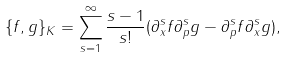Convert formula to latex. <formula><loc_0><loc_0><loc_500><loc_500>\{ f , g \} _ { K } = \sum _ { s = 1 } ^ { \infty } \frac { s - 1 } { s ! } ( \partial _ { x } ^ { s } f \partial _ { p } ^ { s } g - \partial _ { p } ^ { s } f \partial _ { x } ^ { s } g ) ,</formula> 